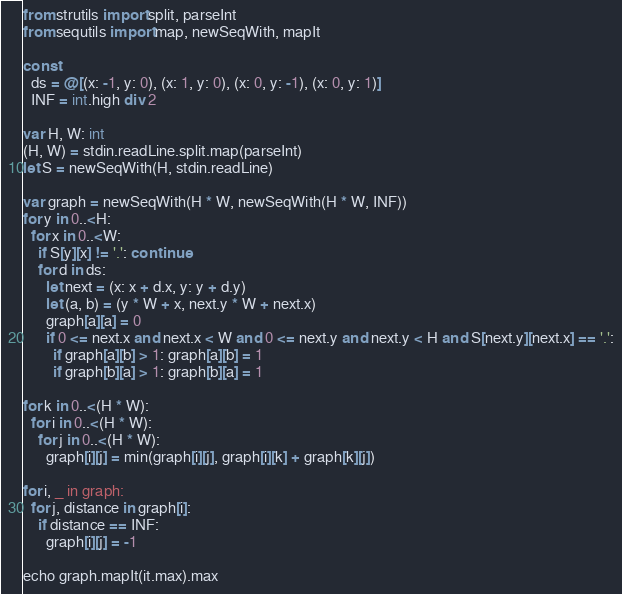<code> <loc_0><loc_0><loc_500><loc_500><_Nim_>from strutils import split, parseInt
from sequtils import map, newSeqWith, mapIt

const
  ds = @[(x: -1, y: 0), (x: 1, y: 0), (x: 0, y: -1), (x: 0, y: 1)]
  INF = int.high div 2

var H, W: int
(H, W) = stdin.readLine.split.map(parseInt)
let S = newSeqWith(H, stdin.readLine)

var graph = newSeqWith(H * W, newSeqWith(H * W, INF))
for y in 0..<H:
  for x in 0..<W:
    if S[y][x] != '.': continue
    for d in ds:
      let next = (x: x + d.x, y: y + d.y)
      let (a, b) = (y * W + x, next.y * W + next.x)
      graph[a][a] = 0
      if 0 <= next.x and next.x < W and 0 <= next.y and next.y < H and S[next.y][next.x] == '.':
        if graph[a][b] > 1: graph[a][b] = 1
        if graph[b][a] > 1: graph[b][a] = 1

for k in 0..<(H * W):
  for i in 0..<(H * W):
    for j in 0..<(H * W):
      graph[i][j] = min(graph[i][j], graph[i][k] + graph[k][j])

for i, _ in graph:
  for j, distance in graph[i]:
    if distance == INF:
      graph[i][j] = -1

echo graph.mapIt(it.max).max
</code> 